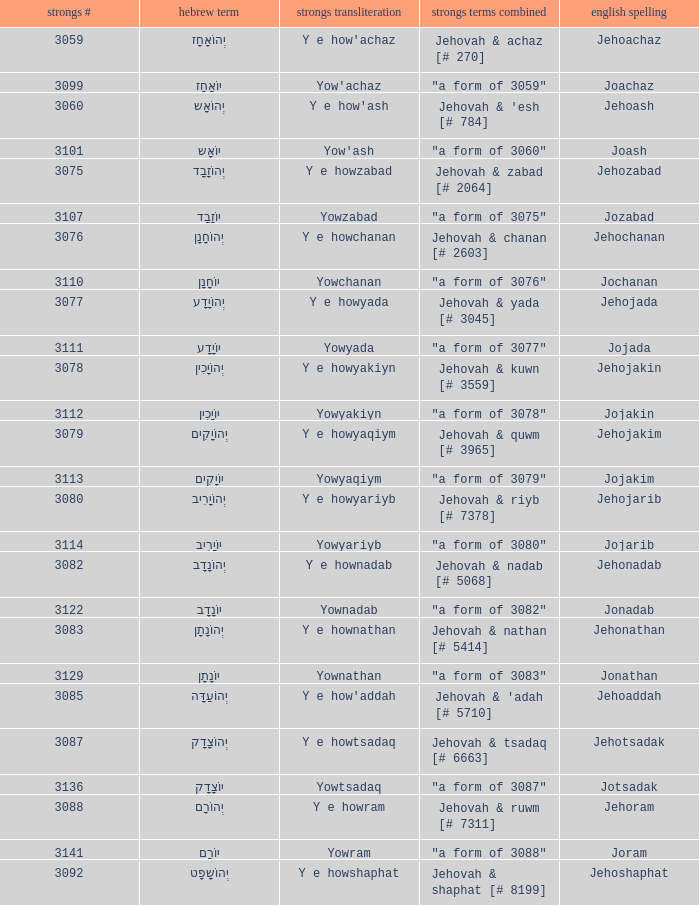What is the strongs # of the english spelling word jehojakin? 3078.0. 